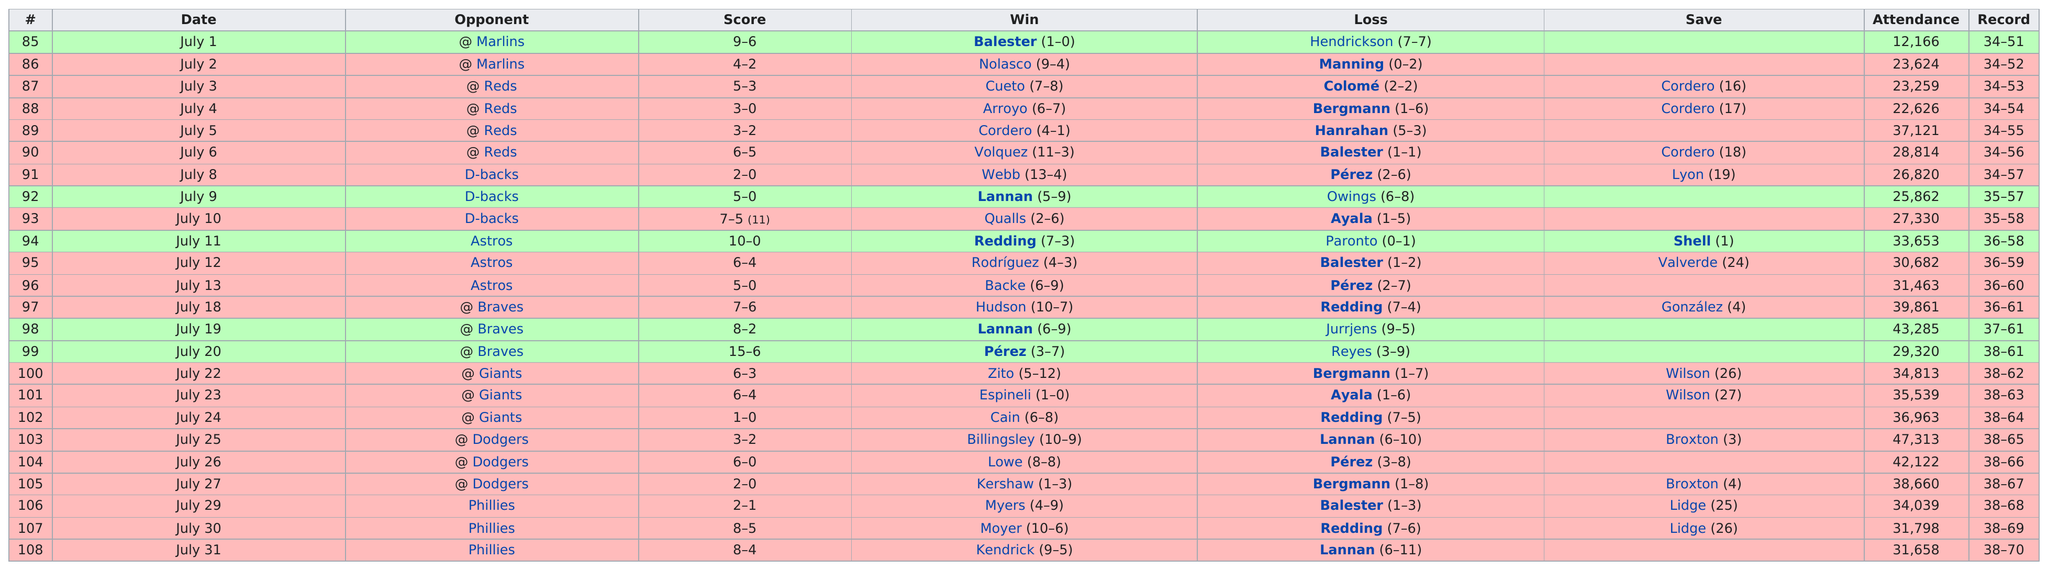Draw attention to some important aspects in this diagram. Out of the total number of games played, the opponent won 4 times when they were the Reds. The first date listed for the opponent "Reds" is July 3. The date with the highest attendance was July 25. According to the records of the Phillies games held from July 29-31, the difference in the number of wins between Moyer and Myers was six. The opponent in the first game with more than 35,000 attendees was the Reds. 